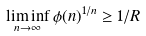<formula> <loc_0><loc_0><loc_500><loc_500>\liminf _ { n \to \infty } \phi ( n ) ^ { 1 / n } \geq 1 / R</formula> 